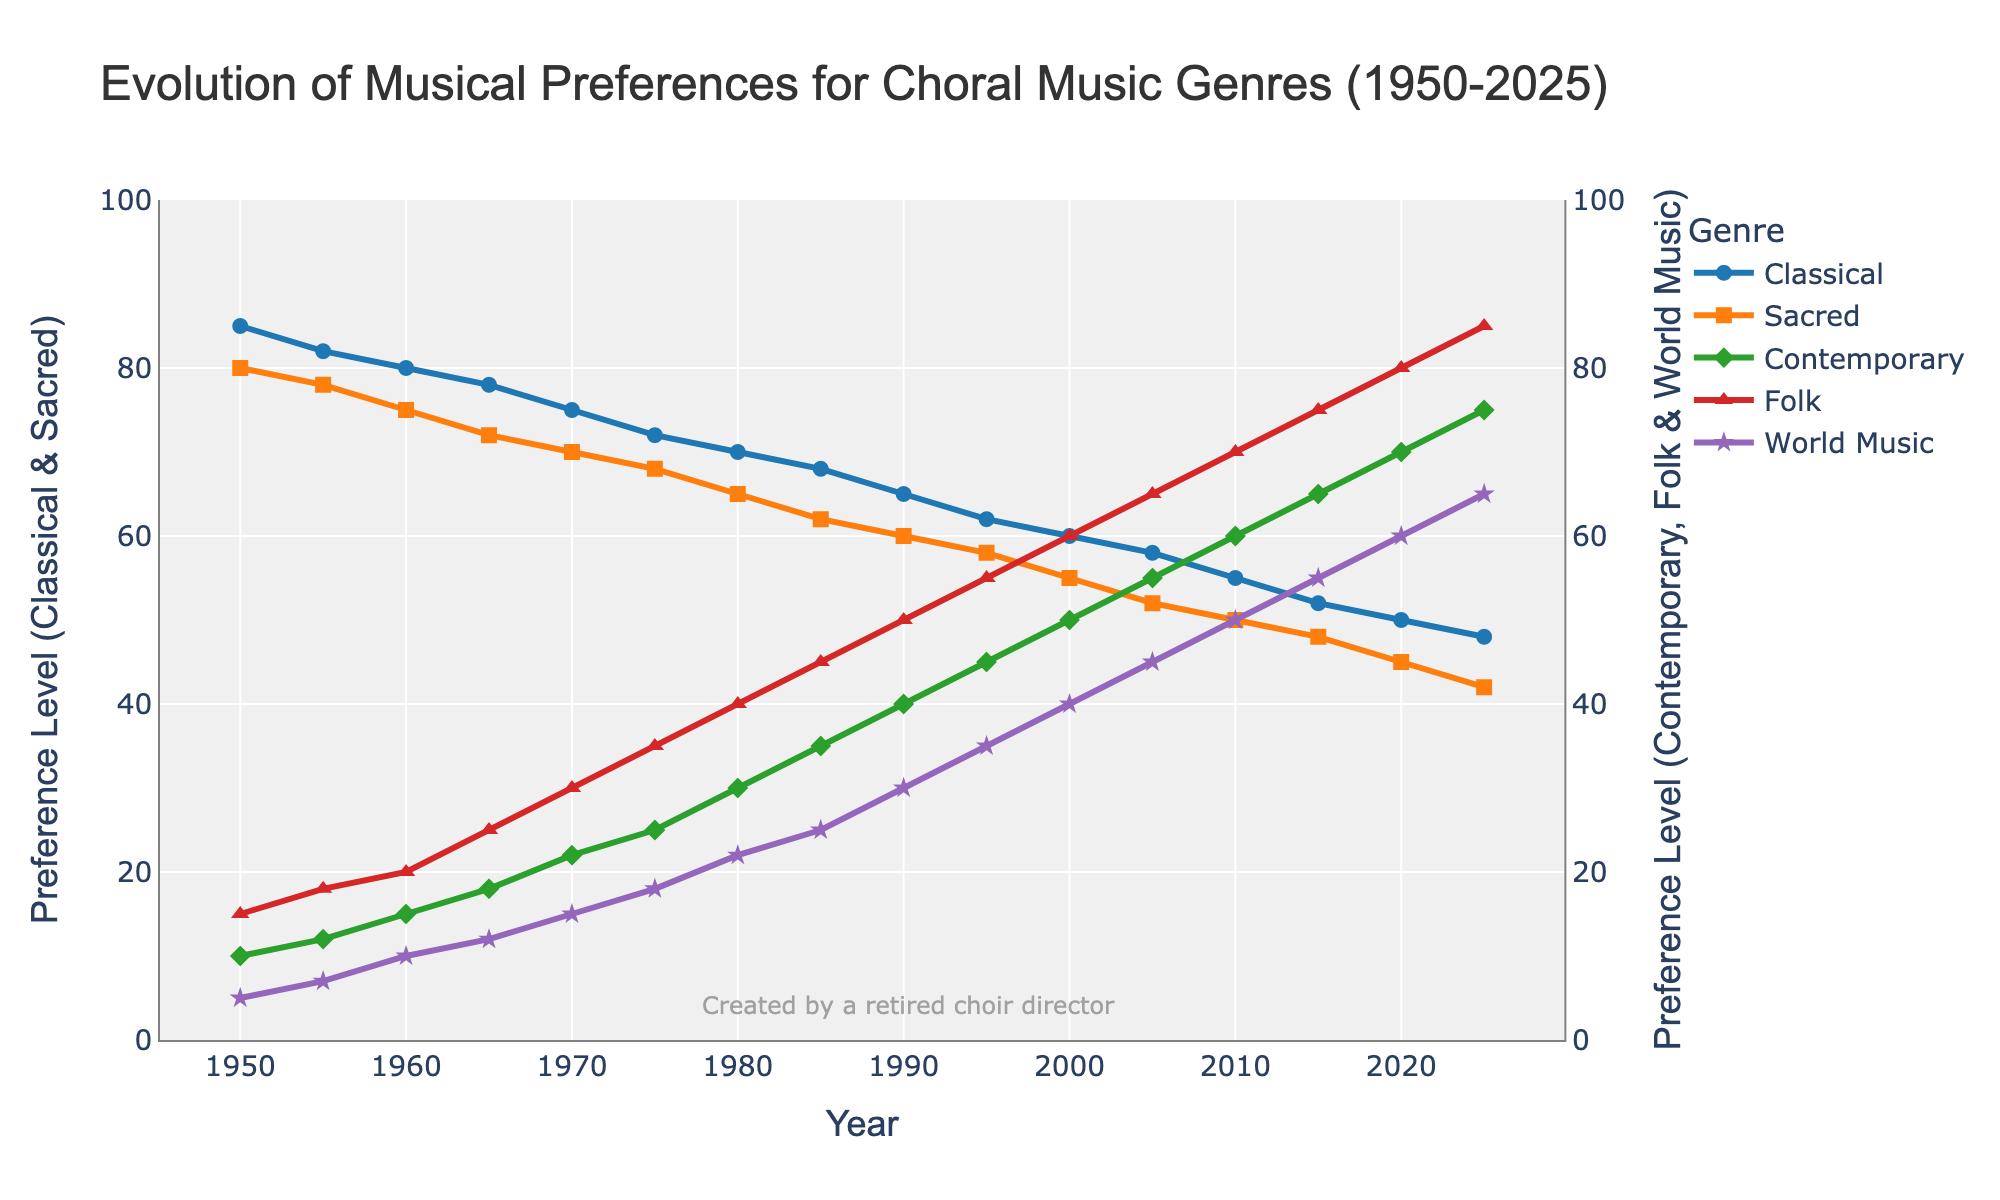What's the overall trend for Classical music popularity from 1950 to 2025? By looking at the line representing Classical music, we can observe if it is generally increasing, decreasing, or remaining constant. The blue line (representing Classical) shows a steady decrease from 85 in 1950 to 48 in 2025.
Answer: Decreasing How does the popularity of Contemporary music in 2000 compare to that in 2020? The green line representing Contemporary music shows its rise from around 50 in 2000 to about 70 in 2020. By subtracting the values, we see an increase of 20 points.
Answer: Higher in 2020 In which year do Sacred and Classical music first fall below contemporary music in preference levels? By examining the intersection points of the lines, we see that in 2005, Sacred and Classical fall below Contemporary music as the Sacred and Classical lines are lower than the Contemporary line.
Answer: 2005 Between Sacred and Folk music, which one shows a constant increase in preference over the years and which one shows a decrease? By examining the orange line (Sacred) and red line (Folk), we can see that Sacred music steadily decreases while Folk music consistently increases over the years.
Answer: Sacred decreases, Folk increases Considering the year 2010, what is the approximate visual difference in preference levels between Classical and Folk music? In 2010, Classical is at around 55, and Folk is at 70. By subtracting the values (70-55), we get a difference of 15.
Answer: 15 Which genre has the highest preference level in 2025? By looking at the endpoints of all lines in the year 2025, the highest point belongs to Folk music (red line) at 85.
Answer: Folk In what year do Folk and World music preferences first exceed those of Sacred music? Looking at the graph, around the year 2000, both the red line (Folk) and purple line (World Music) cross above the orange line (Sacred).
Answer: 2000 What is the combined preference level of Sacred and Classical music in 1960? By adding the values for Sacred (75) and Classical (80) for the year 1960, we get a combined preference level of 155.
Answer: 155 At which period does World Music show the most significant increase in preference? Observing the purple line (World Music), the steepest rise occurs between 2000 to 2025, where it climbs rapidly from around 40 to 65.
Answer: 2000-2025 Comparing Classical and Contemporary music, which one had a higher percentage decrease/increase in preference from 1950 to 2025? The Classical music decreased from 85 in 1950 to 48 in 2025, a 43.53% decrease ([(85-48)/85]*100). Contemporary music increased from 10 to 75, a 650% increase ([(75-10)/10]*100).
Answer: Contemporary increased more 